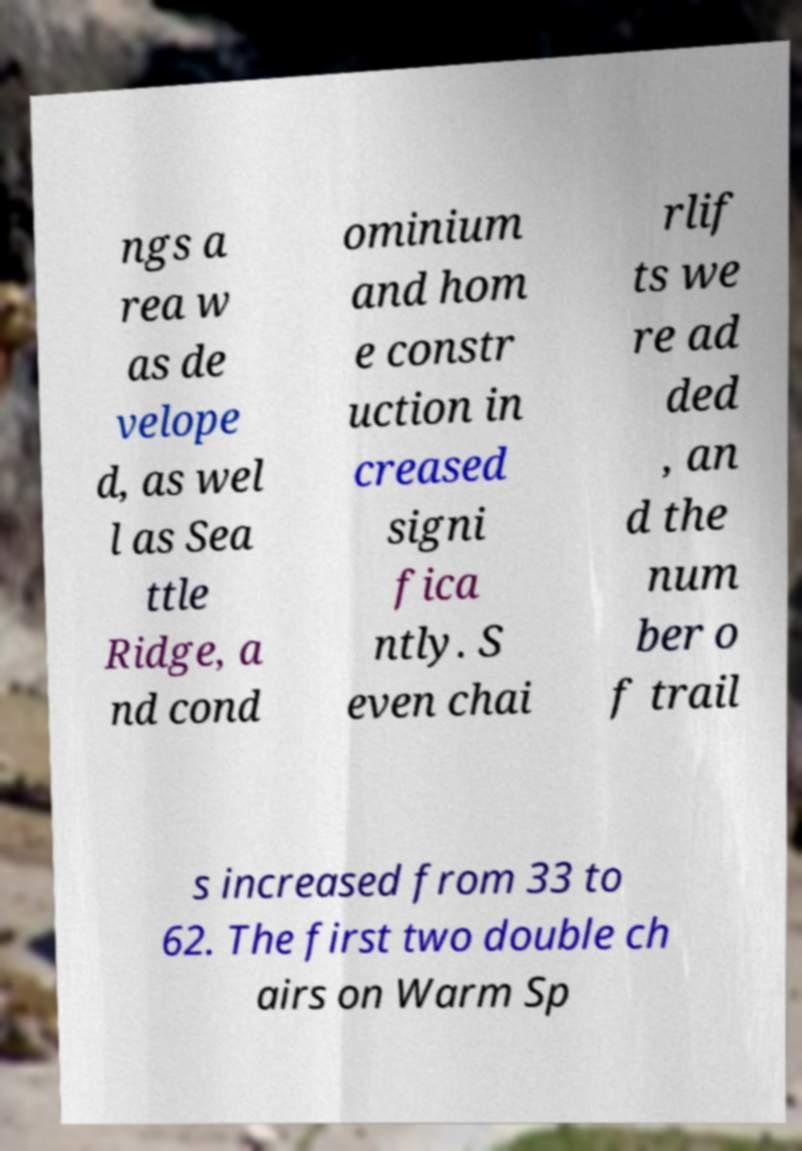Could you extract and type out the text from this image? ngs a rea w as de velope d, as wel l as Sea ttle Ridge, a nd cond ominium and hom e constr uction in creased signi fica ntly. S even chai rlif ts we re ad ded , an d the num ber o f trail s increased from 33 to 62. The first two double ch airs on Warm Sp 